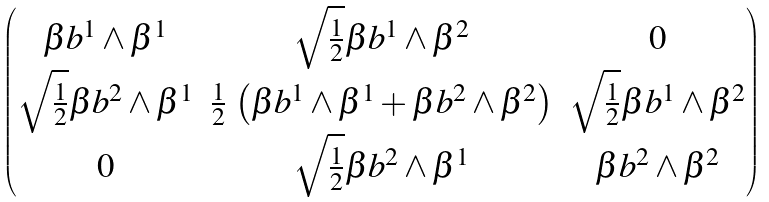<formula> <loc_0><loc_0><loc_500><loc_500>\begin{pmatrix} \beta b ^ { 1 } \wedge \beta ^ { 1 } & \sqrt { \frac { 1 } { 2 } } \beta b ^ { 1 } \wedge \beta ^ { 2 } & 0 \\ \sqrt { \frac { 1 } { 2 } } \beta b ^ { 2 } \wedge \beta ^ { 1 } & \frac { 1 } { 2 } \, \left ( \beta b ^ { 1 } \wedge \beta ^ { 1 } + \beta b ^ { 2 } \wedge \beta ^ { 2 } \right ) & \sqrt { \frac { 1 } { 2 } } \beta b ^ { 1 } \wedge \beta ^ { 2 } \\ 0 & \sqrt { \frac { 1 } { 2 } } \beta b ^ { 2 } \wedge \beta ^ { 1 } & \beta b ^ { 2 } \wedge \beta ^ { 2 } \end{pmatrix}</formula> 